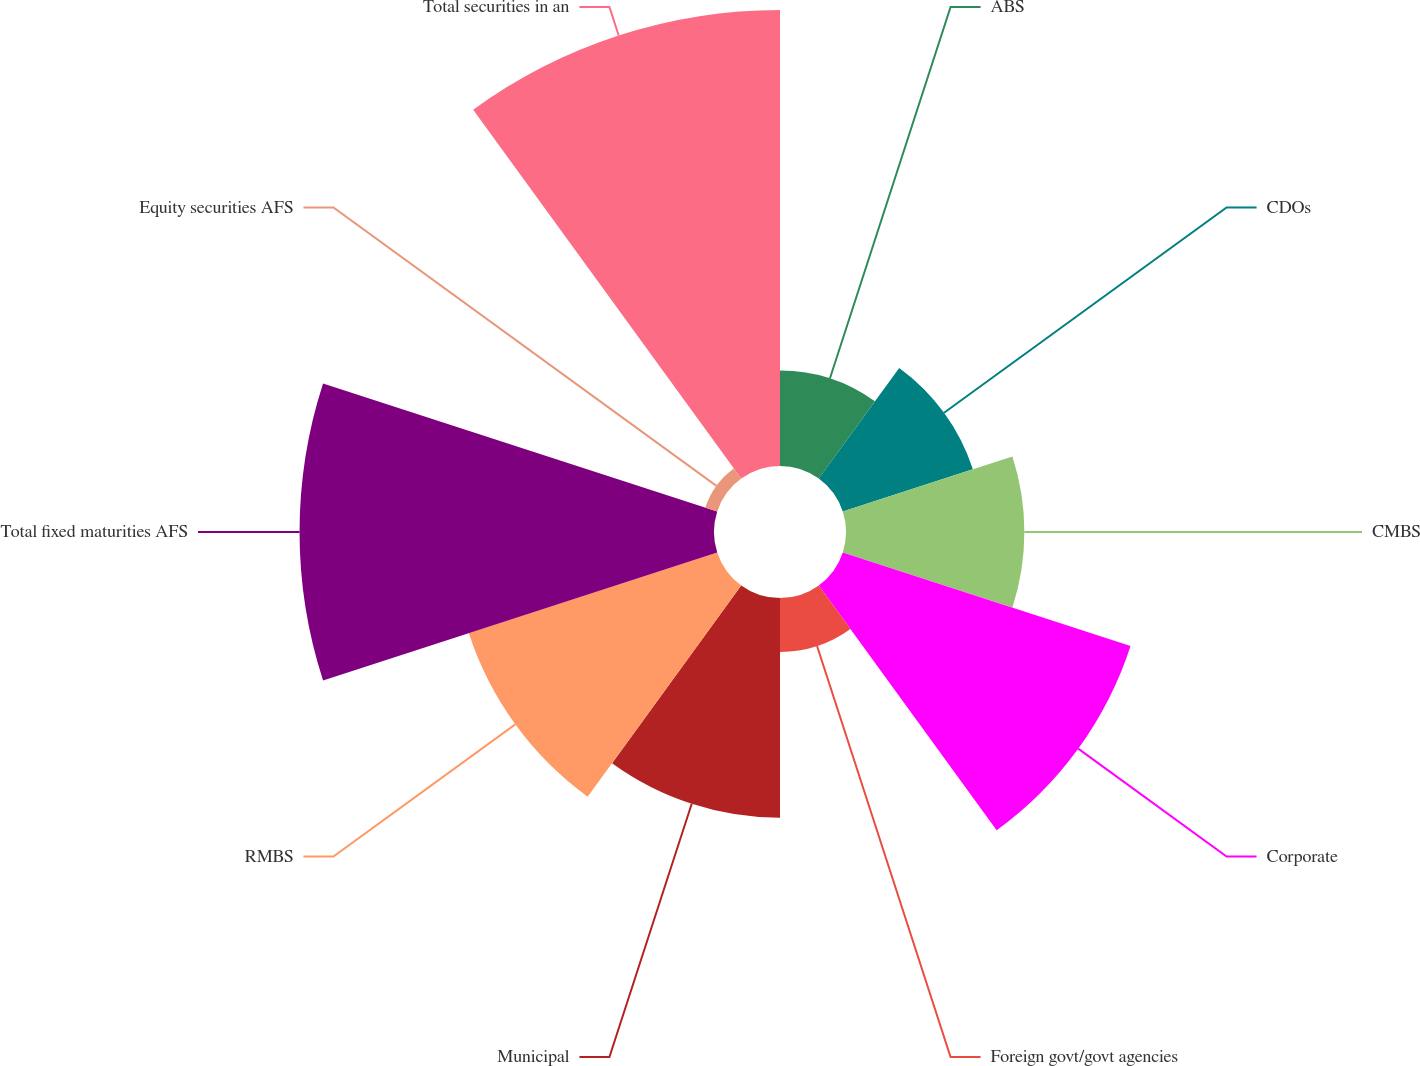<chart> <loc_0><loc_0><loc_500><loc_500><pie_chart><fcel>ABS<fcel>CDOs<fcel>CMBS<fcel>Corporate<fcel>Foreign govt/govt agencies<fcel>Municipal<fcel>RMBS<fcel>Total fixed maturities AFS<fcel>Equity securities AFS<fcel>Total securities in an<nl><fcel>4.48%<fcel>6.42%<fcel>8.37%<fcel>14.2%<fcel>2.53%<fcel>10.31%<fcel>12.26%<fcel>19.45%<fcel>0.59%<fcel>21.4%<nl></chart> 